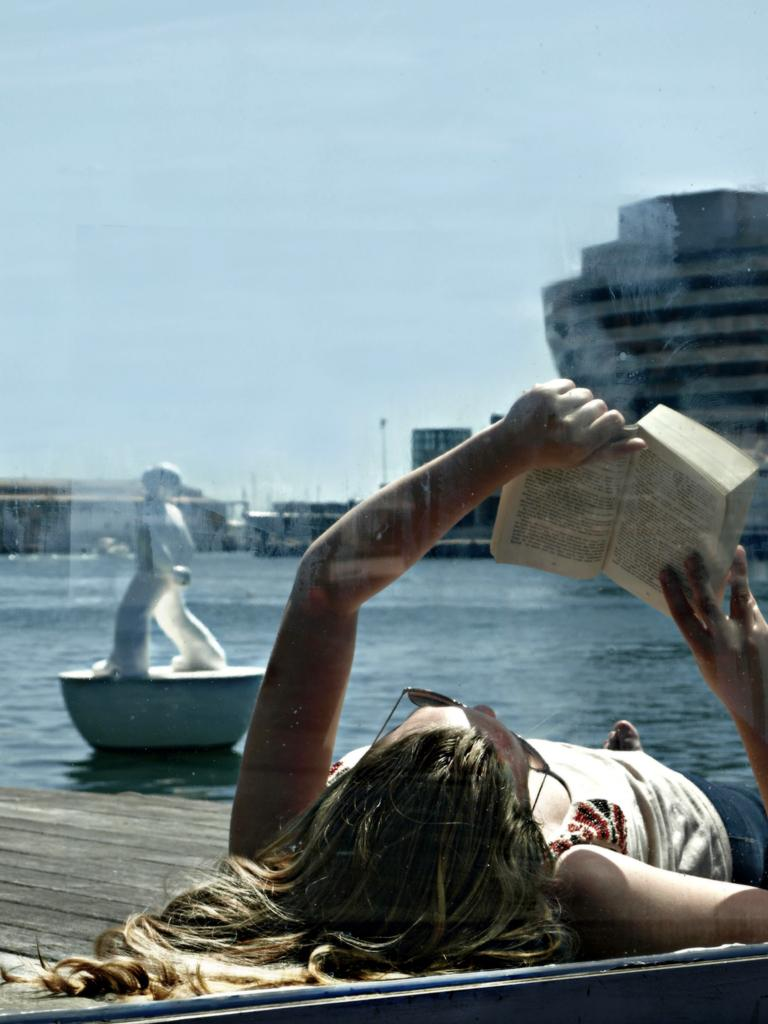Who is present in the image? There is a woman in the image. What is the woman doing in the image? The woman is laying on a surface and holding a book. What can be seen in the background of the image? There is water, a statue, buildings, a pole, and a cloudy sky visible in the background of the image. How long does it take for the woman to ride her bike in the image? There is no bike present in the image, so it is not possible to determine how long it would take for the woman to ride a bike. 